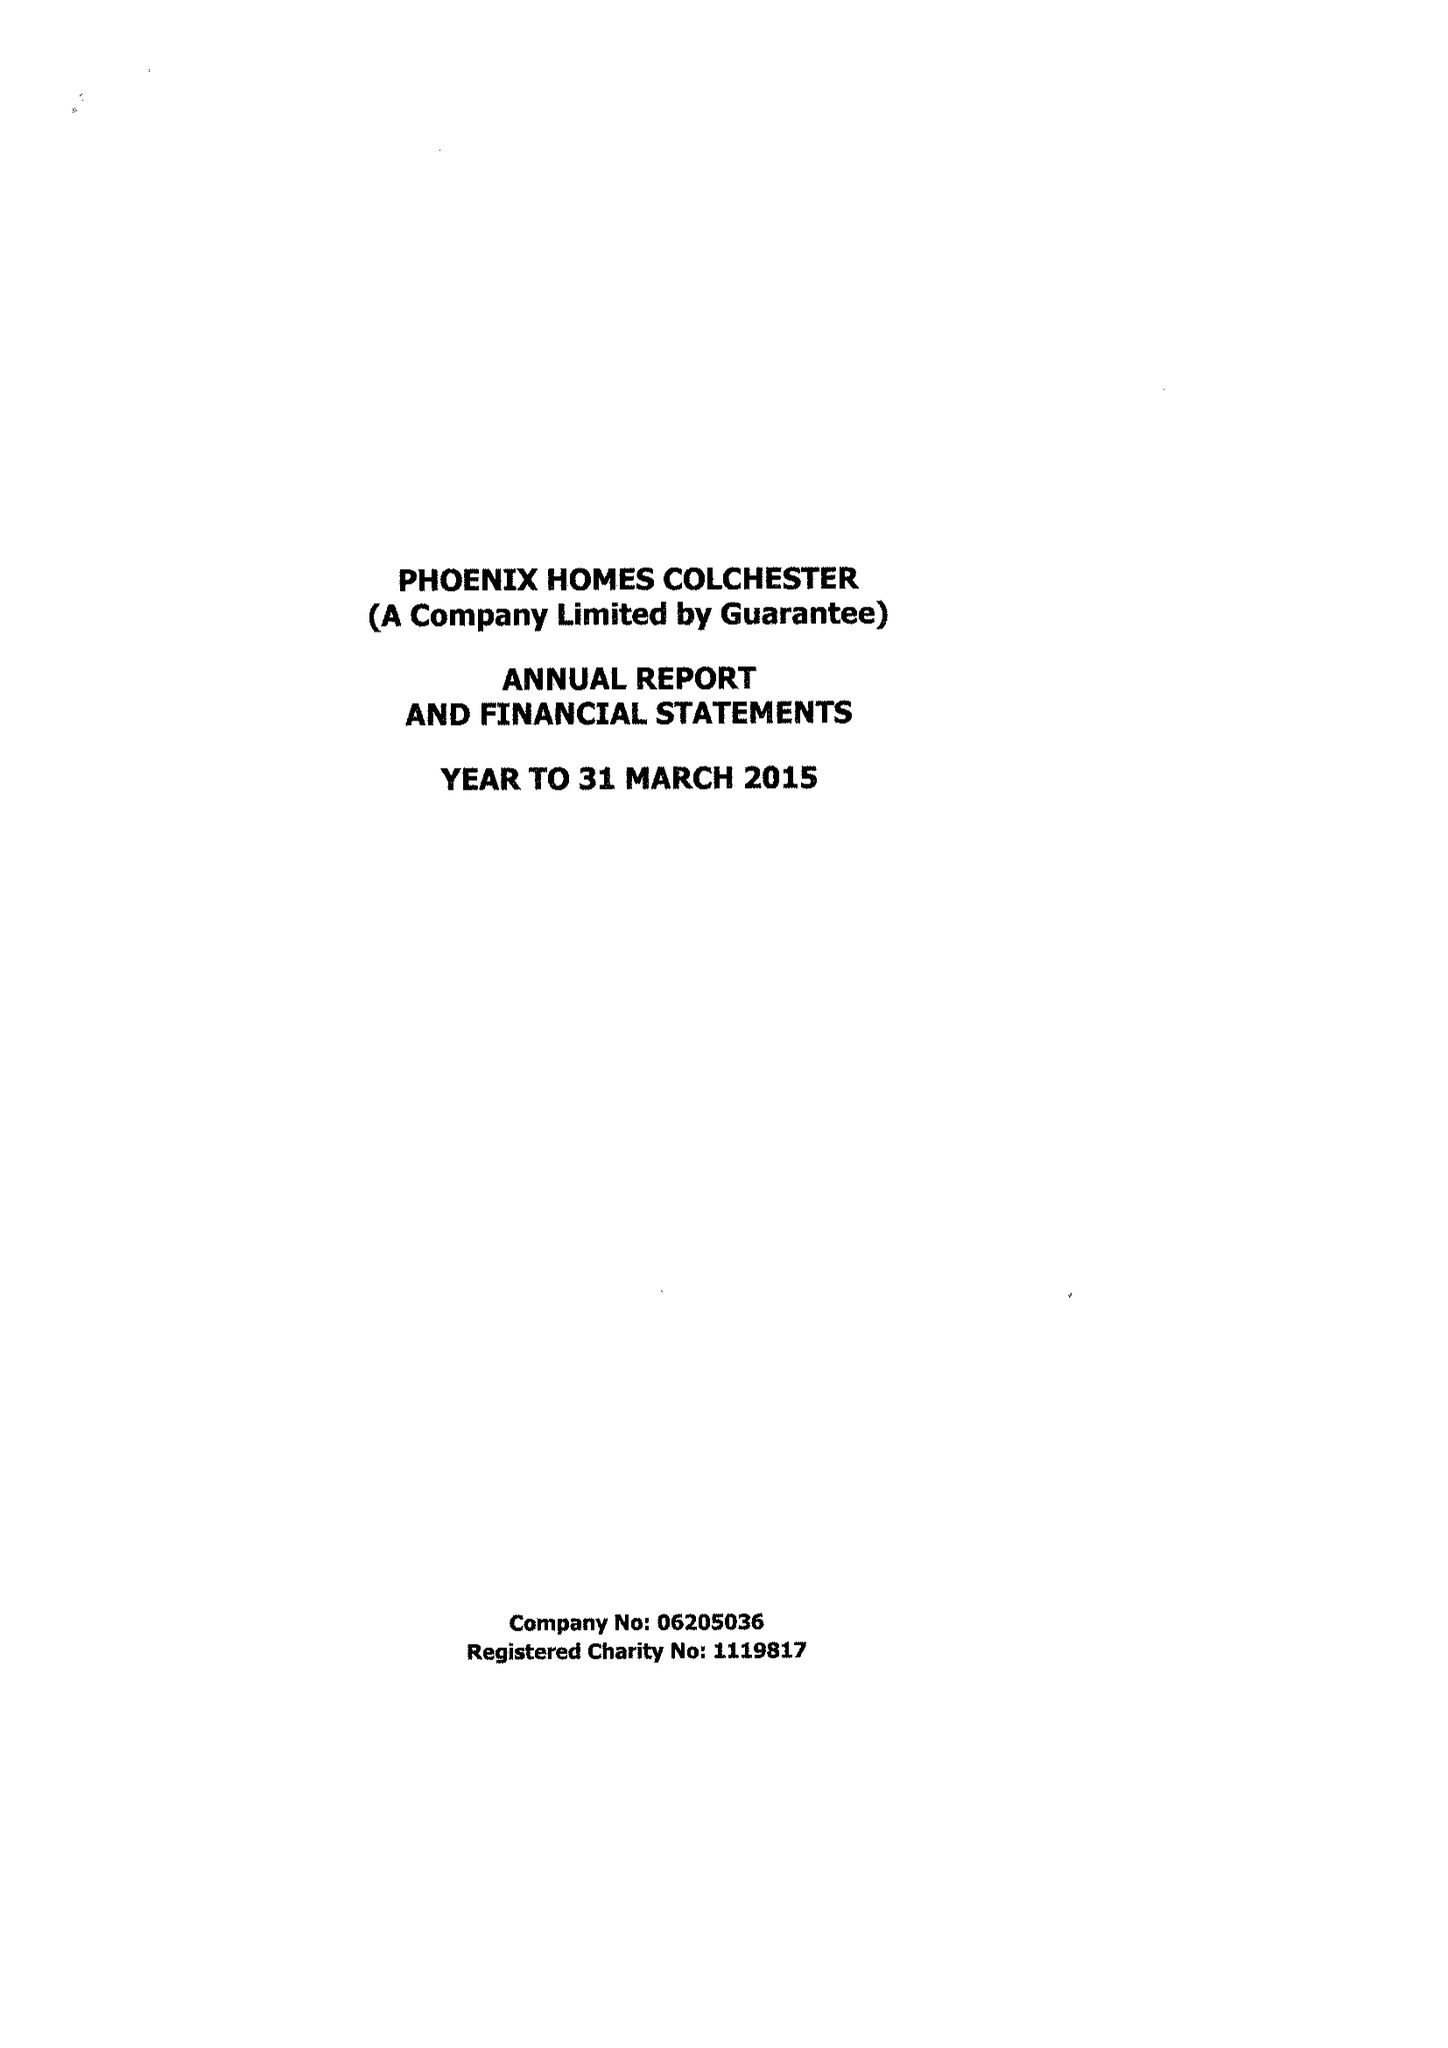What is the value for the income_annually_in_british_pounds?
Answer the question using a single word or phrase. 395948.00 